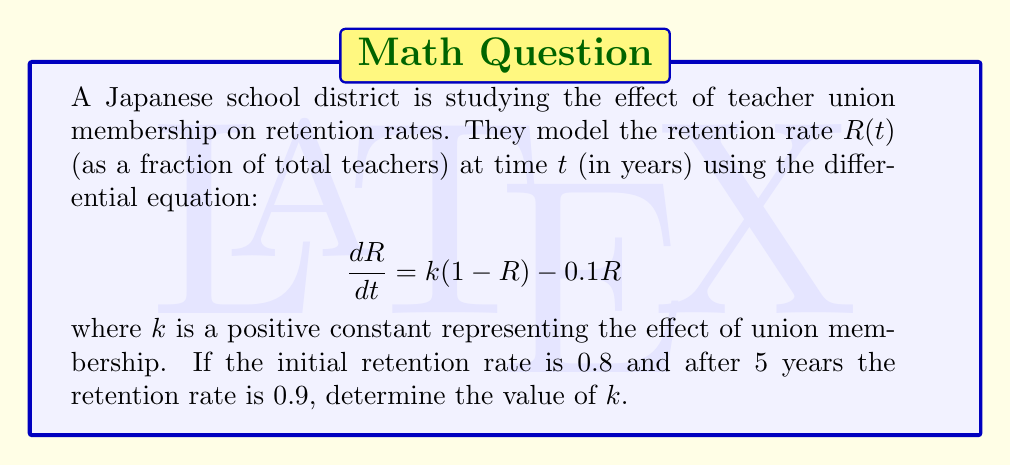What is the answer to this math problem? To solve this problem, we'll follow these steps:

1) First, we need to solve the differential equation. It's a first-order linear differential equation.

2) The general solution to this equation is:

   $$R(t) = \frac{k}{k+0.1} + Ce^{-(k+0.1)t}$$

   where $C$ is a constant determined by the initial condition.

3) Using the initial condition $R(0) = 0.8$, we can find $C$:

   $$0.8 = \frac{k}{k+0.1} + C$$
   $$C = 0.8 - \frac{k}{k+0.1}$$

4) Now we can write the full solution:

   $$R(t) = \frac{k}{k+0.1} + (0.8 - \frac{k}{k+0.1})e^{-(k+0.1)t}$$

5) We're told that after 5 years, $R(5) = 0.9$. Let's substitute this:

   $$0.9 = \frac{k}{k+0.1} + (0.8 - \frac{k}{k+0.1})e^{-5(k+0.1)}$$

6) This equation can't be solved algebraically for $k$. We need to use numerical methods.

7) Using a graphing calculator or computer software, we can find that the solution to this equation is approximately:

   $$k \approx 0.2498$$

Therefore, the value of $k$ that satisfies the conditions is approximately 0.2498.
Answer: $k \approx 0.2498$ 